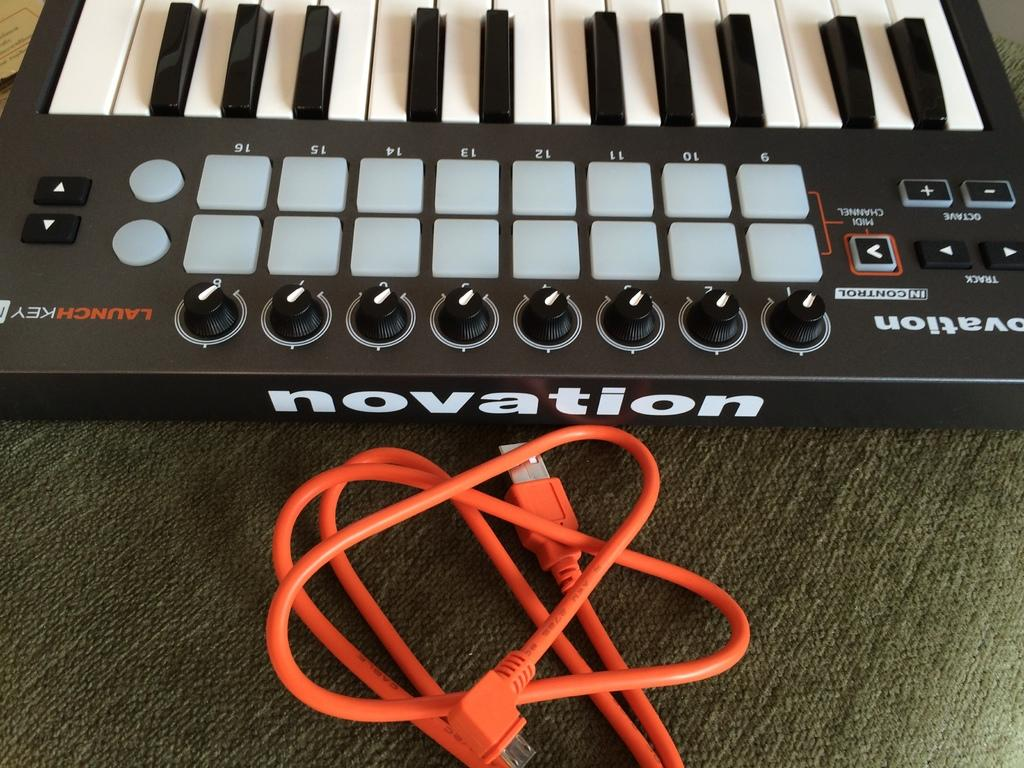What musical instrument is featured in the image? There is a piano keyboard in the image. What else can be seen in the image besides the piano keyboard? There is a cable in the image. Can you see a toad sitting on the piano keyboard in the image? No, there is no toad present in the image. What type of form does the cable take in the image? The cable's form cannot be determined from the image alone, as it is a two-dimensional representation. 